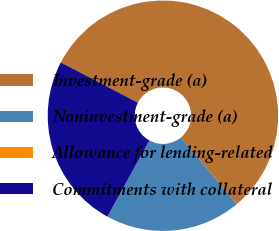<chart> <loc_0><loc_0><loc_500><loc_500><pie_chart><fcel>Investment-grade (a)<fcel>Noninvestment-grade (a)<fcel>Allowance for lending-related<fcel>Commitments with collateral<nl><fcel>56.28%<fcel>19.04%<fcel>0.01%<fcel>24.66%<nl></chart> 